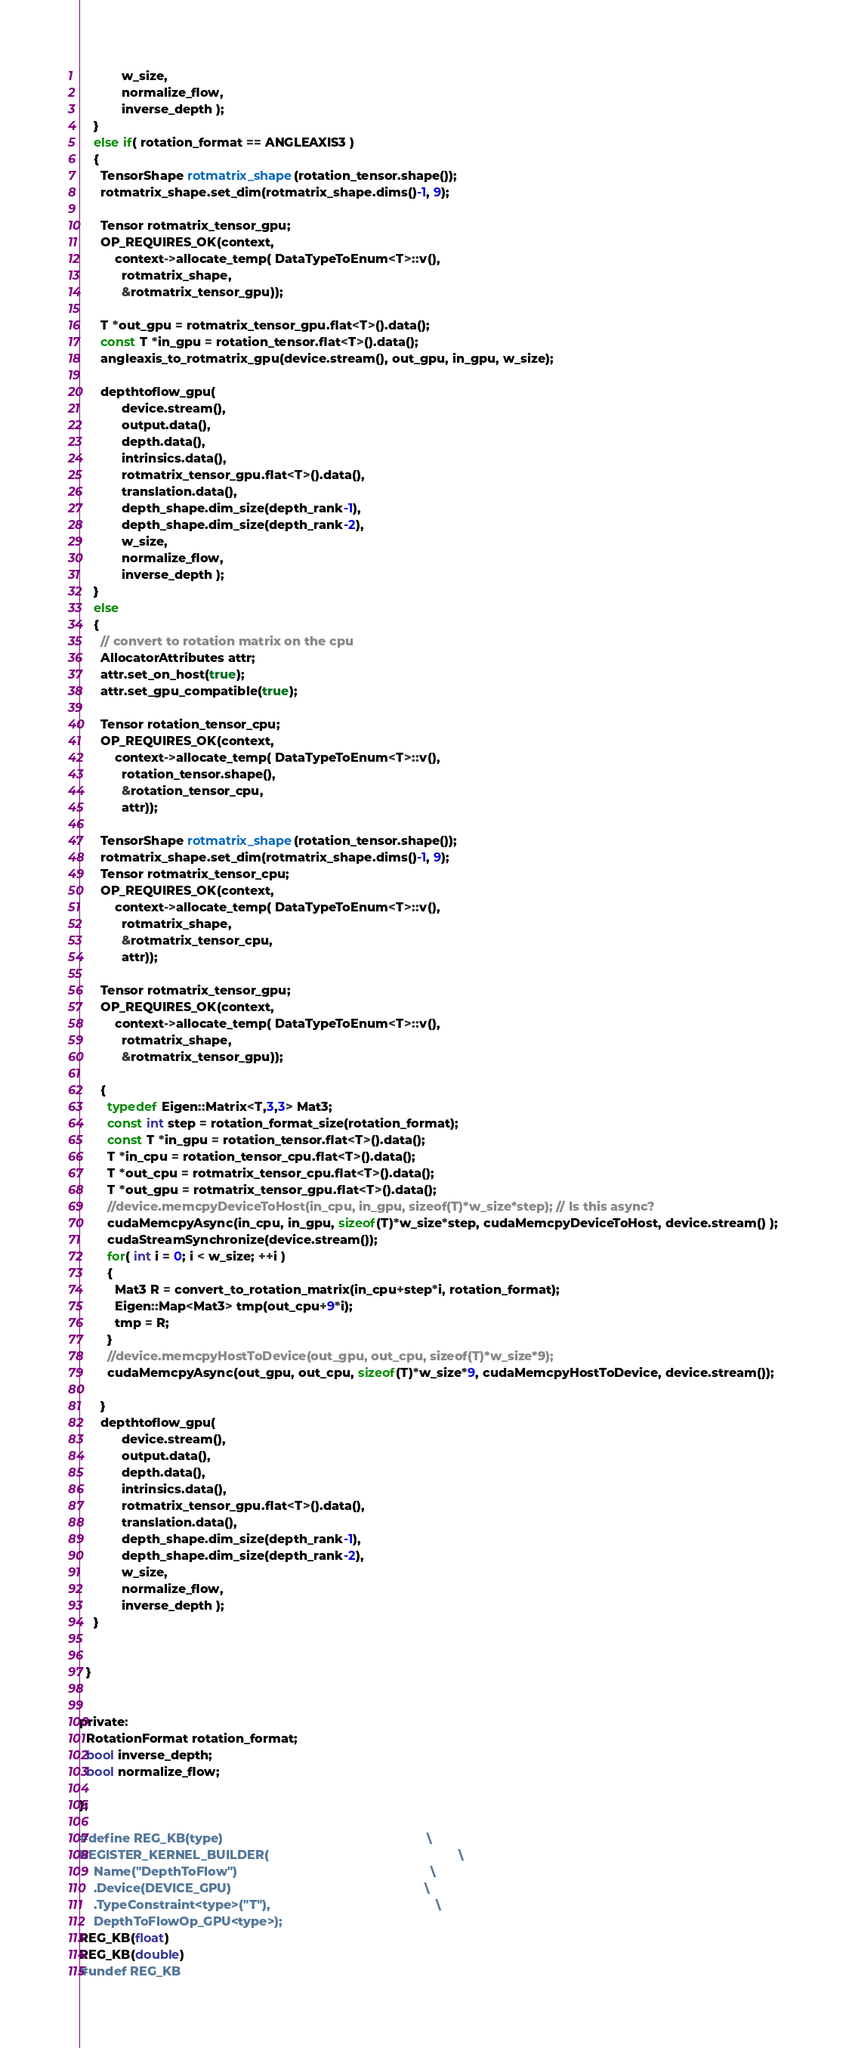Convert code to text. <code><loc_0><loc_0><loc_500><loc_500><_Cuda_>            w_size,
            normalize_flow,
            inverse_depth );
    }
    else if( rotation_format == ANGLEAXIS3 )
    {
      TensorShape rotmatrix_shape(rotation_tensor.shape());
      rotmatrix_shape.set_dim(rotmatrix_shape.dims()-1, 9);

      Tensor rotmatrix_tensor_gpu;
      OP_REQUIRES_OK(context, 
          context->allocate_temp( DataTypeToEnum<T>::v(), 
            rotmatrix_shape, 
            &rotmatrix_tensor_gpu));
      
      T *out_gpu = rotmatrix_tensor_gpu.flat<T>().data();
      const T *in_gpu = rotation_tensor.flat<T>().data();
      angleaxis_to_rotmatrix_gpu(device.stream(), out_gpu, in_gpu, w_size);

      depthtoflow_gpu( 
            device.stream(),
            output.data(),
            depth.data(),
            intrinsics.data(),
            rotmatrix_tensor_gpu.flat<T>().data(),
            translation.data(),
            depth_shape.dim_size(depth_rank-1),
            depth_shape.dim_size(depth_rank-2),
            w_size,
            normalize_flow,
            inverse_depth );
    }
    else
    {
      // convert to rotation matrix on the cpu
      AllocatorAttributes attr;
      attr.set_on_host(true);
      attr.set_gpu_compatible(true);
      
      Tensor rotation_tensor_cpu;
      OP_REQUIRES_OK(context, 
          context->allocate_temp( DataTypeToEnum<T>::v(), 
            rotation_tensor.shape(), 
            &rotation_tensor_cpu,
            attr));

      TensorShape rotmatrix_shape(rotation_tensor.shape());
      rotmatrix_shape.set_dim(rotmatrix_shape.dims()-1, 9);
      Tensor rotmatrix_tensor_cpu;
      OP_REQUIRES_OK(context, 
          context->allocate_temp( DataTypeToEnum<T>::v(), 
            rotmatrix_shape, 
            &rotmatrix_tensor_cpu,
            attr));

      Tensor rotmatrix_tensor_gpu;
      OP_REQUIRES_OK(context, 
          context->allocate_temp( DataTypeToEnum<T>::v(), 
            rotmatrix_shape, 
            &rotmatrix_tensor_gpu));

      {
        typedef Eigen::Matrix<T,3,3> Mat3;
        const int step = rotation_format_size(rotation_format);
        const T *in_gpu = rotation_tensor.flat<T>().data();
        T *in_cpu = rotation_tensor_cpu.flat<T>().data();
        T *out_cpu = rotmatrix_tensor_cpu.flat<T>().data();
        T *out_gpu = rotmatrix_tensor_gpu.flat<T>().data();
        //device.memcpyDeviceToHost(in_cpu, in_gpu, sizeof(T)*w_size*step); // Is this async?
        cudaMemcpyAsync(in_cpu, in_gpu, sizeof(T)*w_size*step, cudaMemcpyDeviceToHost, device.stream() );
        cudaStreamSynchronize(device.stream());
        for( int i = 0; i < w_size; ++i )
        {
          Mat3 R = convert_to_rotation_matrix(in_cpu+step*i, rotation_format);
          Eigen::Map<Mat3> tmp(out_cpu+9*i);
          tmp = R;
        }
        //device.memcpyHostToDevice(out_gpu, out_cpu, sizeof(T)*w_size*9);
        cudaMemcpyAsync(out_gpu, out_cpu, sizeof(T)*w_size*9, cudaMemcpyHostToDevice, device.stream());

      }
      depthtoflow_gpu( 
            device.stream(),
            output.data(),
            depth.data(),
            intrinsics.data(),
            rotmatrix_tensor_gpu.flat<T>().data(),
            translation.data(),
            depth_shape.dim_size(depth_rank-1),
            depth_shape.dim_size(depth_rank-2),
            w_size,
            normalize_flow,
            inverse_depth );
    }

    
  }


private:
  RotationFormat rotation_format;
  bool inverse_depth;
  bool normalize_flow;

};

#define REG_KB(type)                                                          \
REGISTER_KERNEL_BUILDER(                                                      \
    Name("DepthToFlow")                                                       \
    .Device(DEVICE_GPU)                                                       \
    .TypeConstraint<type>("T"),                                               \
    DepthToFlowOp_GPU<type>);                                                  
REG_KB(float)
REG_KB(double)
#undef REG_KB

</code> 